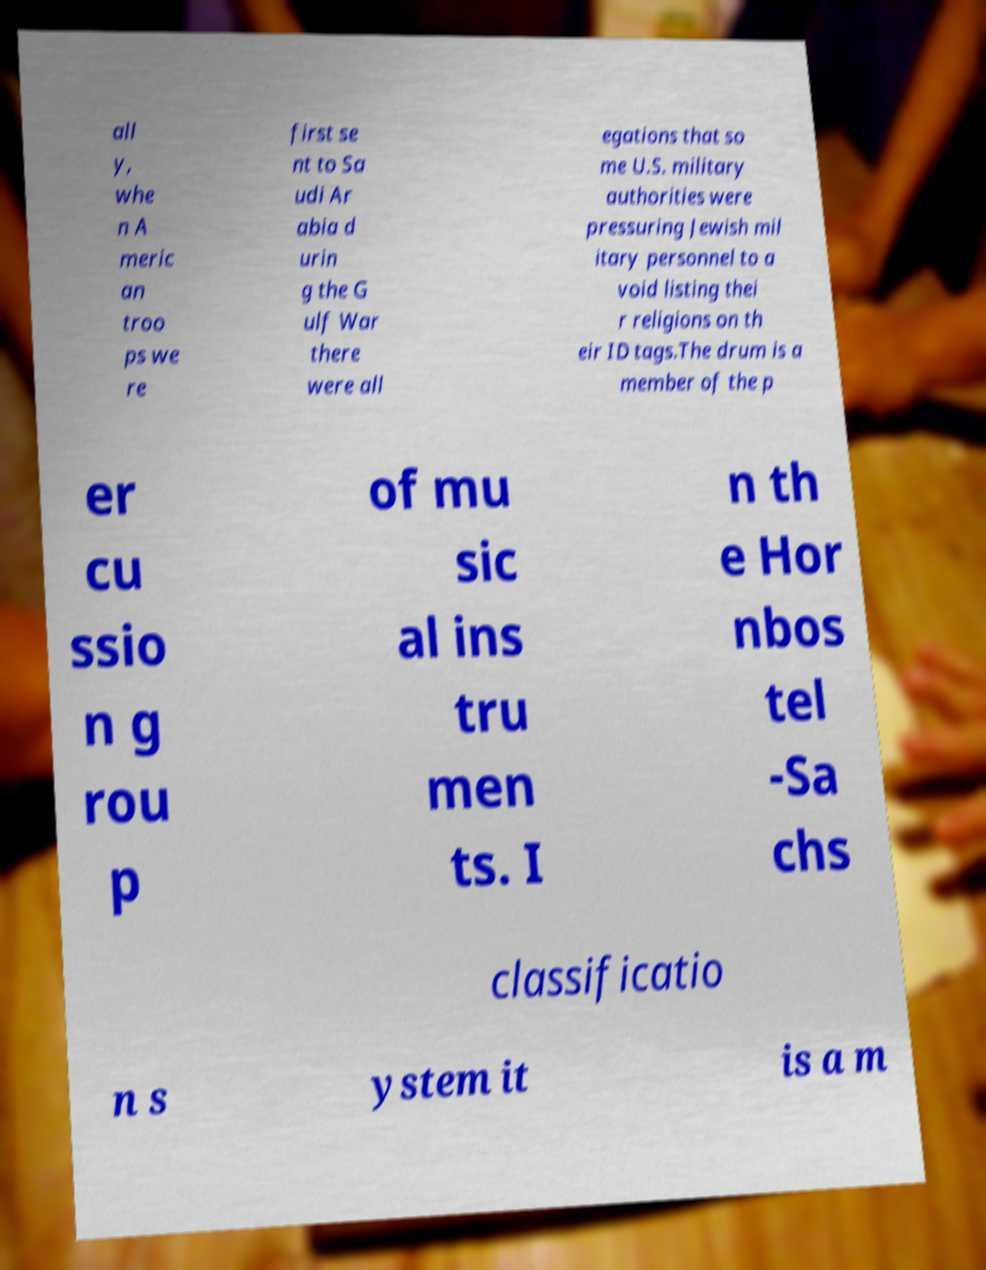Could you assist in decoding the text presented in this image and type it out clearly? all y, whe n A meric an troo ps we re first se nt to Sa udi Ar abia d urin g the G ulf War there were all egations that so me U.S. military authorities were pressuring Jewish mil itary personnel to a void listing thei r religions on th eir ID tags.The drum is a member of the p er cu ssio n g rou p of mu sic al ins tru men ts. I n th e Hor nbos tel -Sa chs classificatio n s ystem it is a m 